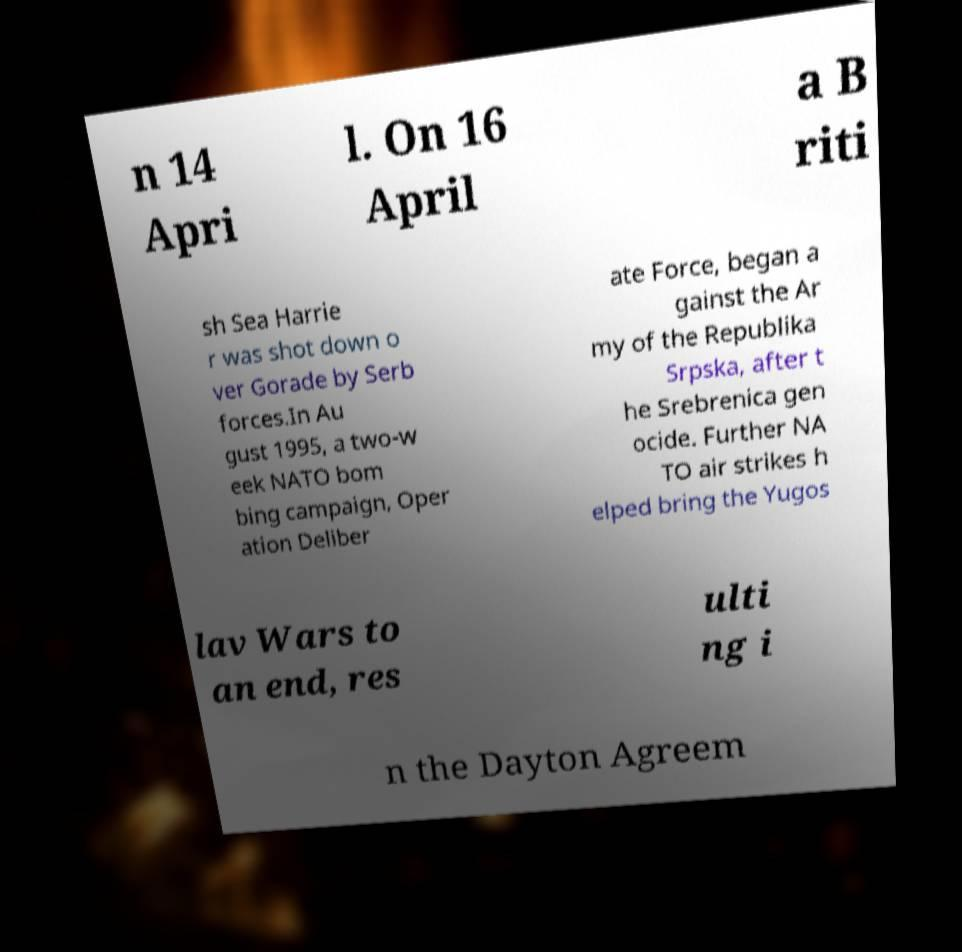There's text embedded in this image that I need extracted. Can you transcribe it verbatim? n 14 Apri l. On 16 April a B riti sh Sea Harrie r was shot down o ver Gorade by Serb forces.In Au gust 1995, a two-w eek NATO bom bing campaign, Oper ation Deliber ate Force, began a gainst the Ar my of the Republika Srpska, after t he Srebrenica gen ocide. Further NA TO air strikes h elped bring the Yugos lav Wars to an end, res ulti ng i n the Dayton Agreem 